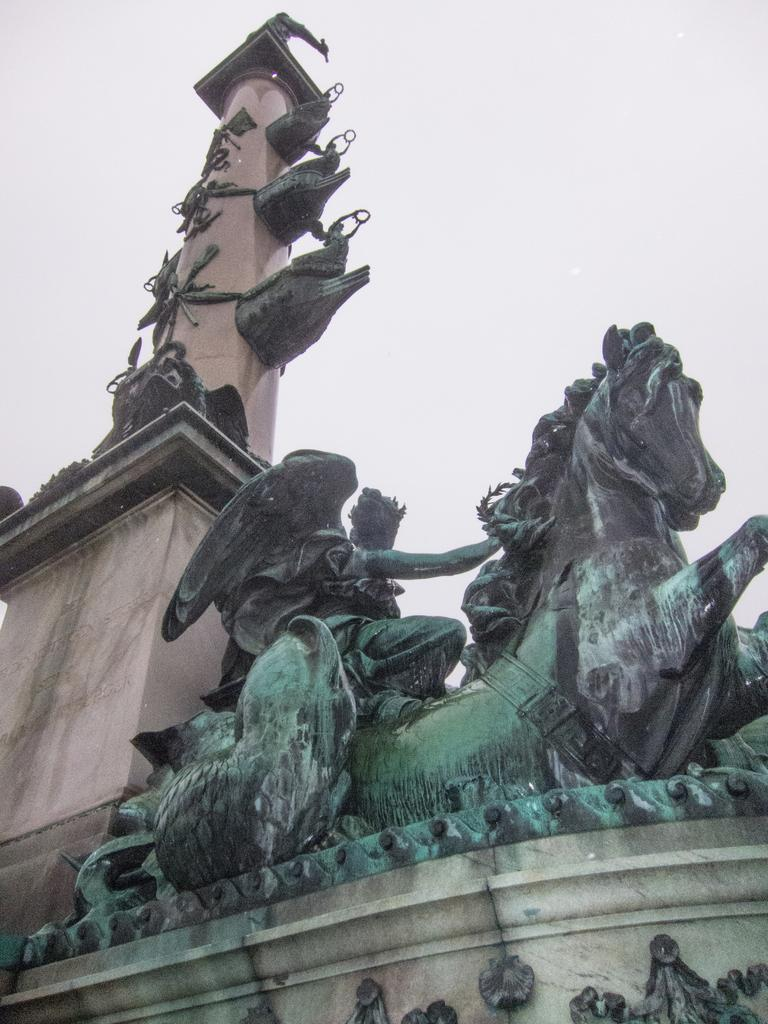What is the main structure in the image? There is a pillar in the image. What artistic element can be seen in the image? There is a sculpture in the image. What can be seen in the distance in the image? The sky is visible in the background of the image. How many beans are present in the image? There are no beans visible in the image. Can you describe the jellyfish in the image? There are no jellyfish present in the image. 